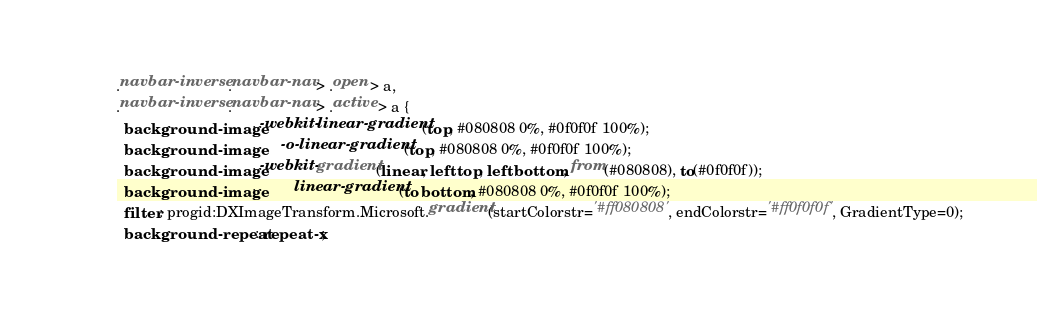Convert code to text. <code><loc_0><loc_0><loc_500><loc_500><_CSS_>.navbar-inverse .navbar-nav > .open > a,
.navbar-inverse .navbar-nav > .active > a {
  background-image: -webkit-linear-gradient(top, #080808 0%, #0f0f0f 100%);
  background-image:      -o-linear-gradient(top, #080808 0%, #0f0f0f 100%);
  background-image: -webkit-gradient(linear, left top, left bottom, from(#080808), to(#0f0f0f));
  background-image:         linear-gradient(to bottom, #080808 0%, #0f0f0f 100%);
  filter: progid:DXImageTransform.Microsoft.gradient(startColorstr='#ff080808', endColorstr='#ff0f0f0f', GradientType=0);
  background-repeat: repeat-x;</code> 